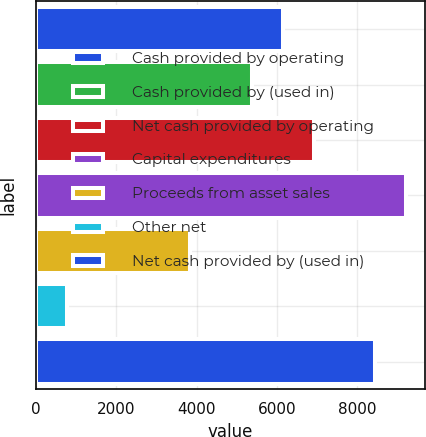Convert chart to OTSL. <chart><loc_0><loc_0><loc_500><loc_500><bar_chart><fcel>Cash provided by operating<fcel>Cash provided by (used in)<fcel>Net cash provided by operating<fcel>Capital expenditures<fcel>Proceeds from asset sales<fcel>Other net<fcel>Net cash provided by (used in)<nl><fcel>6146.2<fcel>5378.3<fcel>6914.1<fcel>9217.8<fcel>3842.5<fcel>770.9<fcel>8449.9<nl></chart> 